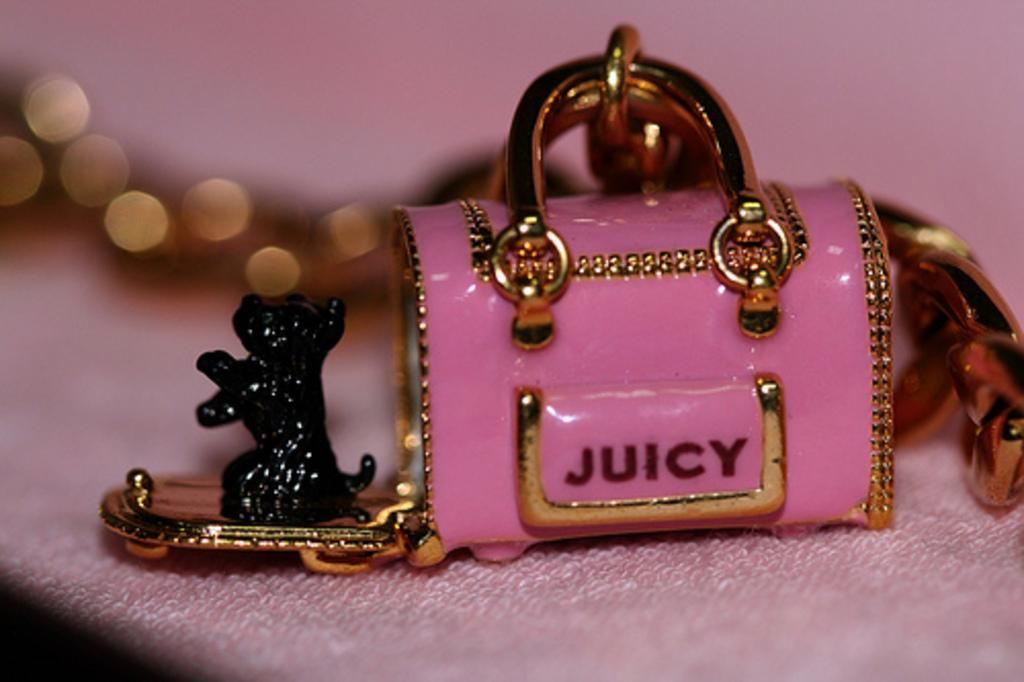What object in the image is used for storing toys? There is a toy bag in the image that is used for storing toys. What can be seen on the toy bag? The toy bag has text on it. What toy is on the table in the image? There is a toy dog on the table. What covers the table in the image? The table has a tablecloth on it. Who is controlling the toy dog in the image? There is no indication in the image that the toy dog is being controlled by anyone. 